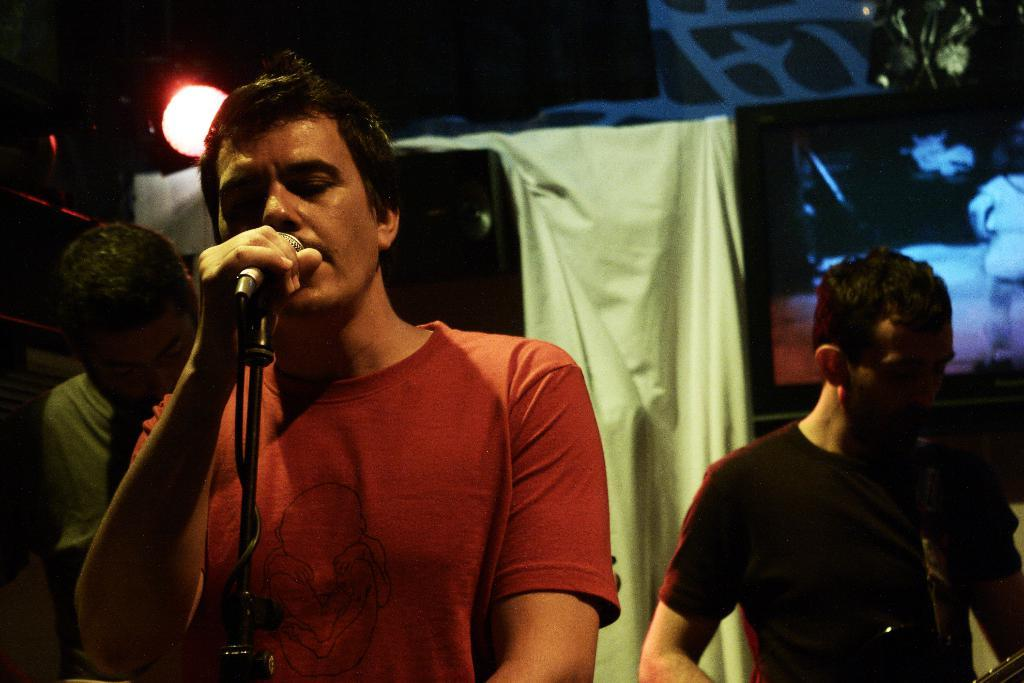How many people are in the image? There are three men in the image. What is the man in the middle doing? The man in the middle is holding a mic. What is the man next to the man with the mic doing? The man next to the man with the mic is playing a musical instrument. What can be seen at the top of the image? There is a light on the top of the image. How many eggs are on the table in the image? There are no eggs present in the image. What type of crack is visible on the man's shirt in the image? There is no crack visible on any of the men's shirts in the image. 